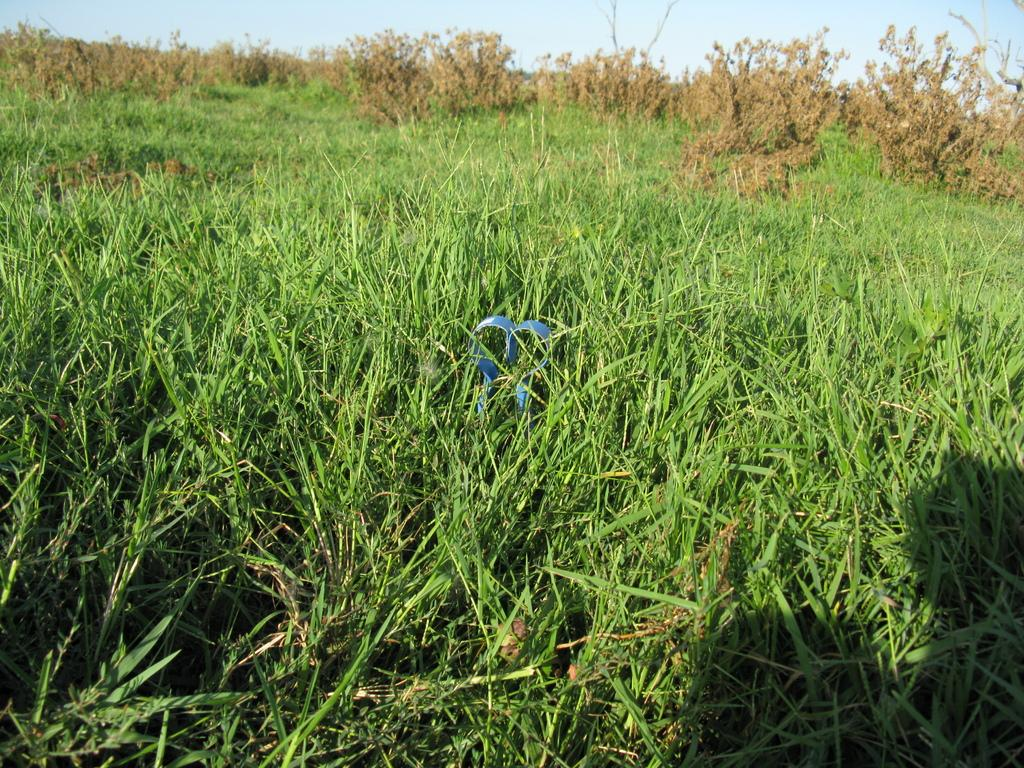What type of vegetation can be seen in the image? There is grass and plants in the image. What part of the natural environment is visible in the image? The sky is visible in the image. How many elbows can be seen in the image? There are no elbows present in the image, as it features grass, plants, and the sky. 